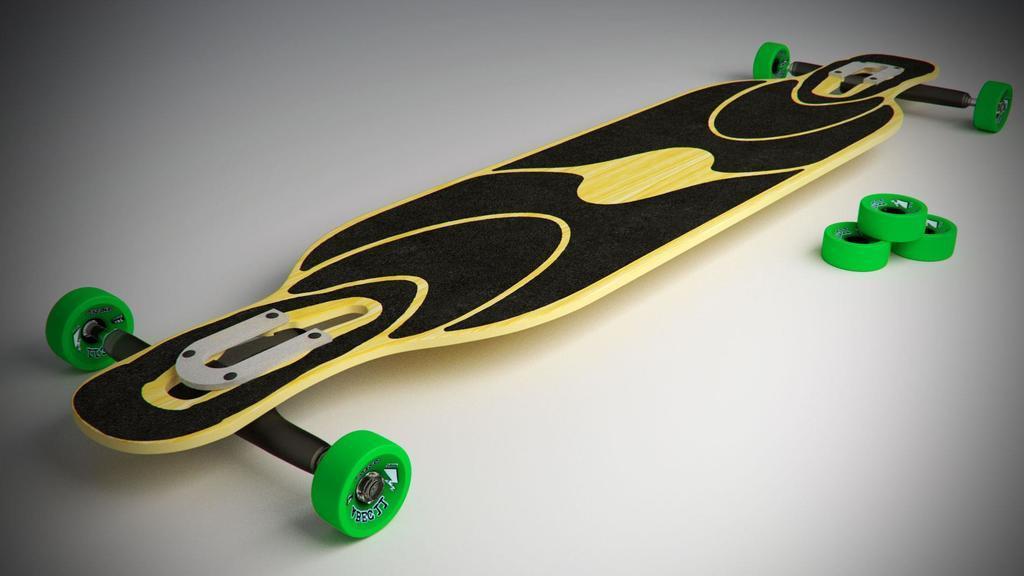Could you give a brief overview of what you see in this image? In the picture I can see the skateboard and there are skateboard wheels on the right side of the picture. 